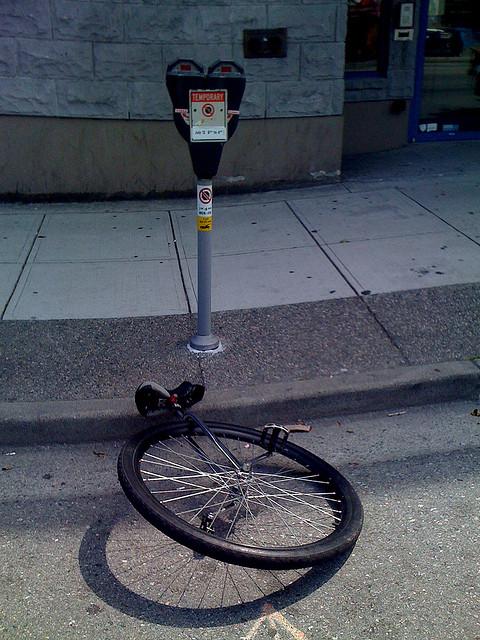Is this metered parking?
Give a very brief answer. Yes. Has someone lost a wheel?
Give a very brief answer. No. What is growing between the sidewalk?
Quick response, please. Nothing. Is this a normal spot for a parking meter?
Concise answer only. Yes. Would this be helpful if there was a fire?
Keep it brief. No. Where did the black spots on the sidewalk come from?
Quick response, please. Gum. Do more people ride this than bicycles?
Quick response, please. No. 